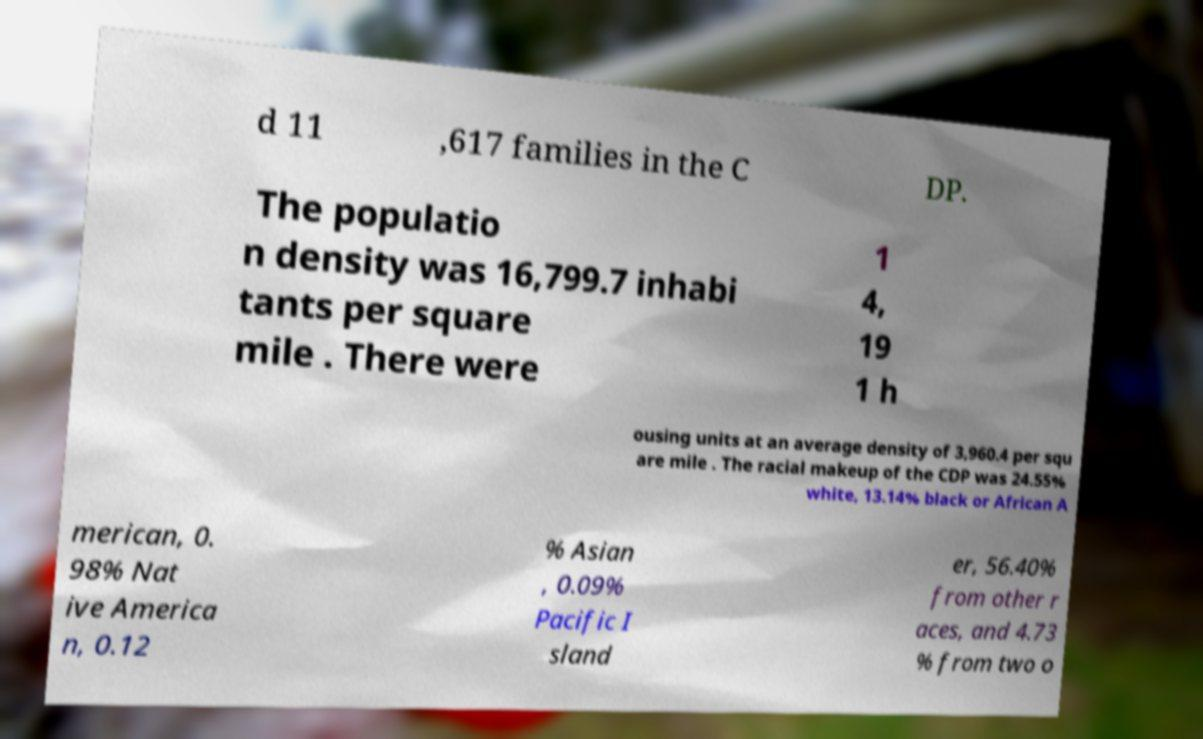Could you extract and type out the text from this image? d 11 ,617 families in the C DP. The populatio n density was 16,799.7 inhabi tants per square mile . There were 1 4, 19 1 h ousing units at an average density of 3,960.4 per squ are mile . The racial makeup of the CDP was 24.55% white, 13.14% black or African A merican, 0. 98% Nat ive America n, 0.12 % Asian , 0.09% Pacific I sland er, 56.40% from other r aces, and 4.73 % from two o 